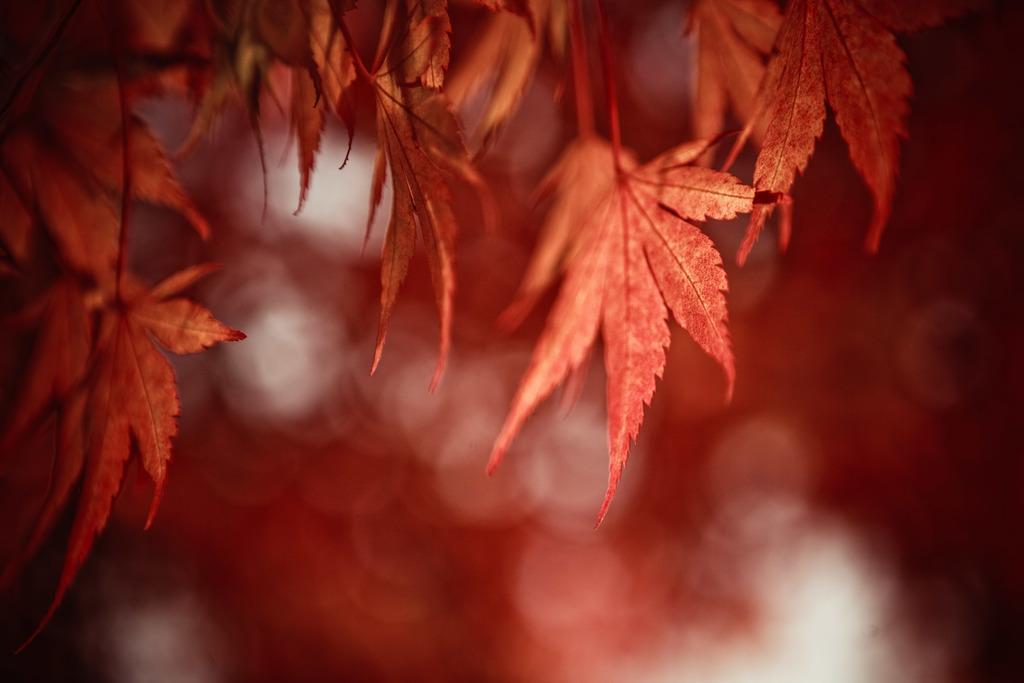What can be seen in the foreground of the image? There are leaves in the foreground of the image. How would you describe the background of the image? The background of the image is blurry. What type of unit is being controlled in the image? There is no unit or control present in the image; it only features leaves in the foreground and a blurry background. 